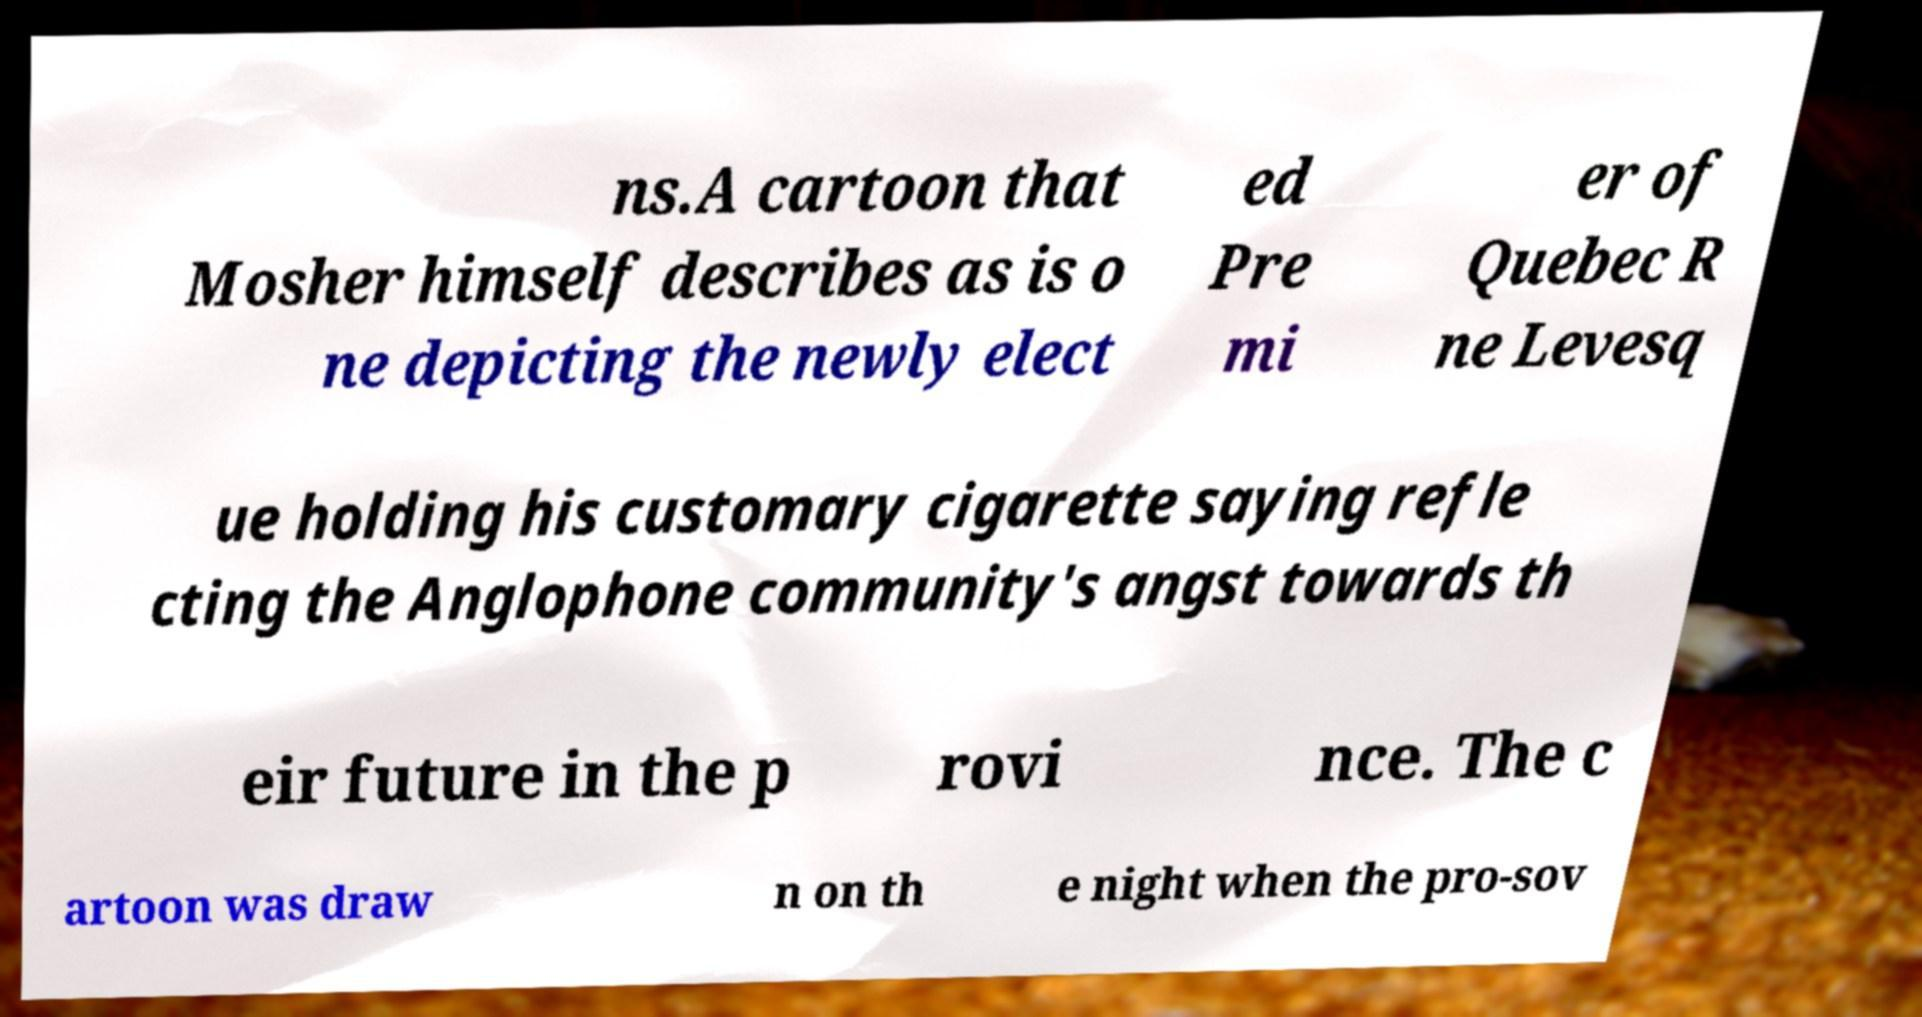Could you extract and type out the text from this image? ns.A cartoon that Mosher himself describes as is o ne depicting the newly elect ed Pre mi er of Quebec R ne Levesq ue holding his customary cigarette saying refle cting the Anglophone community's angst towards th eir future in the p rovi nce. The c artoon was draw n on th e night when the pro-sov 